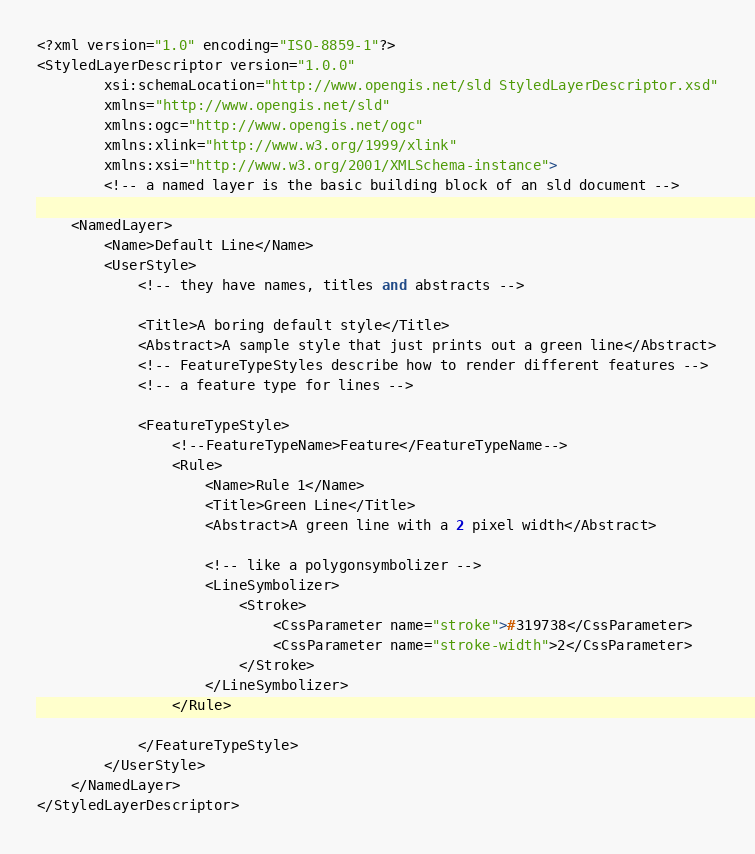Convert code to text. <code><loc_0><loc_0><loc_500><loc_500><_Scheme_><?xml version="1.0" encoding="ISO-8859-1"?>
<StyledLayerDescriptor version="1.0.0"
        xsi:schemaLocation="http://www.opengis.net/sld StyledLayerDescriptor.xsd"
        xmlns="http://www.opengis.net/sld"
        xmlns:ogc="http://www.opengis.net/ogc"
        xmlns:xlink="http://www.w3.org/1999/xlink"
        xmlns:xsi="http://www.w3.org/2001/XMLSchema-instance">
        <!-- a named layer is the basic building block of an sld document -->

    <NamedLayer>
        <Name>Default Line</Name>
        <UserStyle>
            <!-- they have names, titles and abstracts -->

            <Title>A boring default style</Title>
            <Abstract>A sample style that just prints out a green line</Abstract>
            <!-- FeatureTypeStyles describe how to render different features -->
            <!-- a feature type for lines -->

            <FeatureTypeStyle>
                <!--FeatureTypeName>Feature</FeatureTypeName-->
                <Rule>
                    <Name>Rule 1</Name>
                    <Title>Green Line</Title>
                    <Abstract>A green line with a 2 pixel width</Abstract>

                    <!-- like a polygonsymbolizer -->
                    <LineSymbolizer>
                        <Stroke>
                            <CssParameter name="stroke">#319738</CssParameter>
                            <CssParameter name="stroke-width">2</CssParameter>
                        </Stroke>
                    </LineSymbolizer>
                </Rule>

            </FeatureTypeStyle>
        </UserStyle>
    </NamedLayer>
</StyledLayerDescriptor>
</code> 